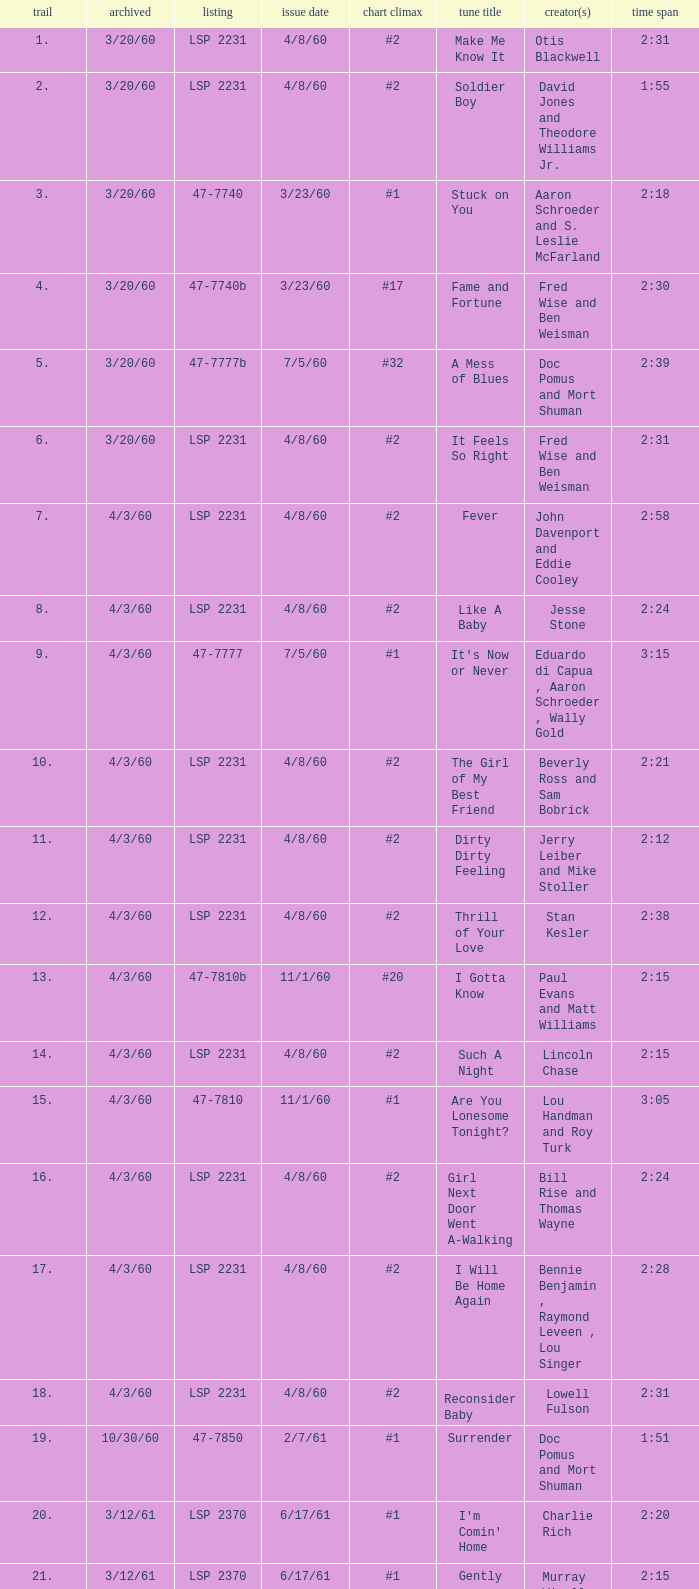On songs that have a release date of 6/17/61, a track larger than 20, and a writer of Woody Harris, what is the chart peak? #1. 